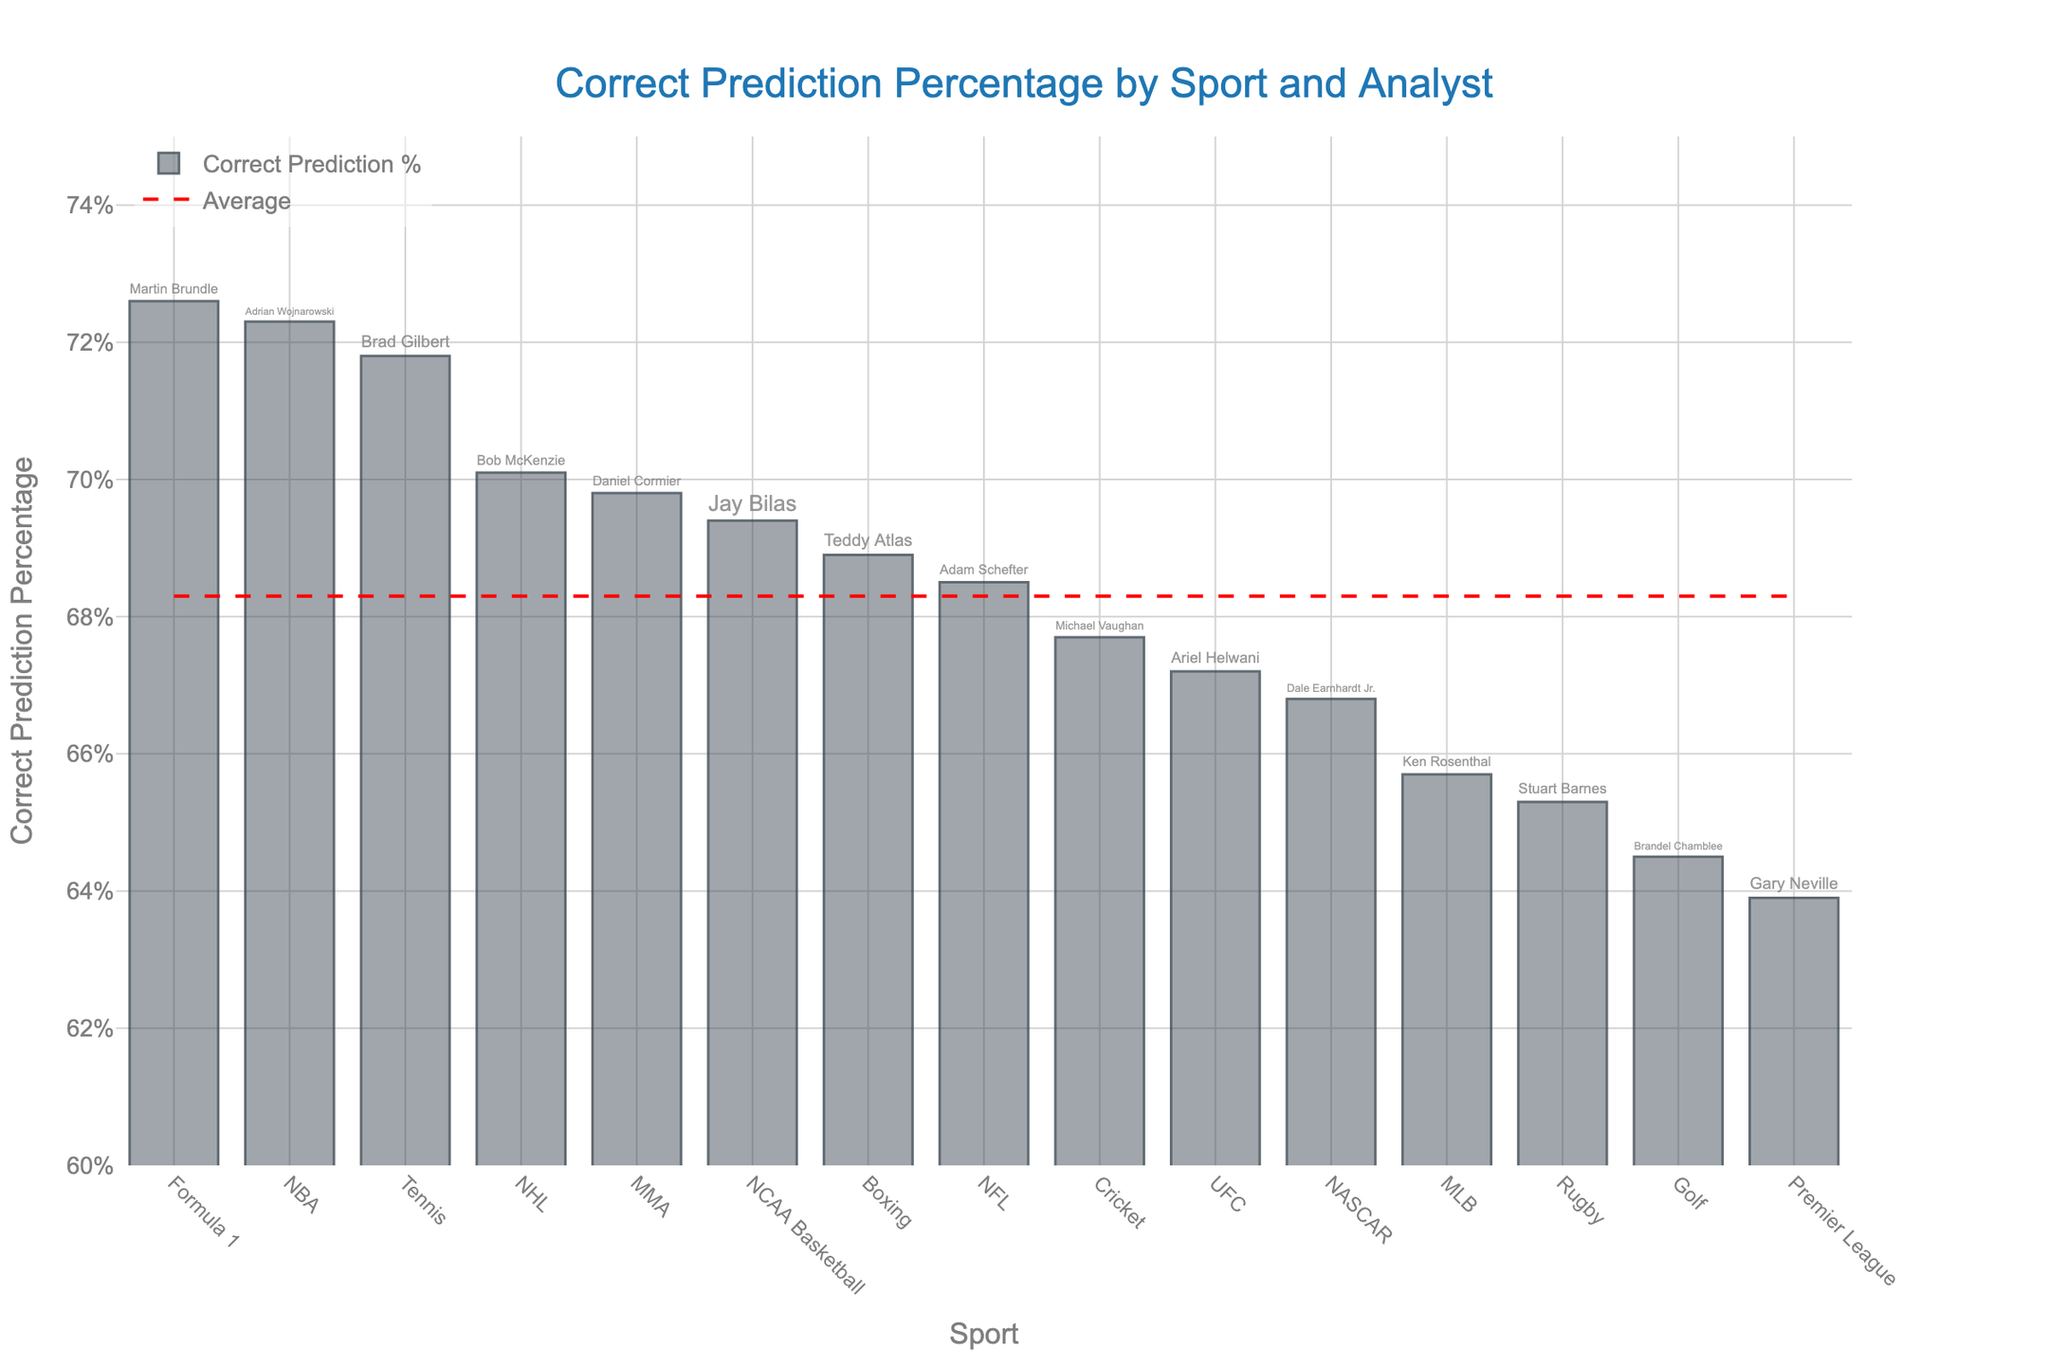What's the percentage of correct predictions made by Adrian Wojnarowski for the NBA? The bar representing the NBA is labeled with the analyst Adrian Wojnarowski, and the bar reaches the 72.3% mark. Thus, the percentage of correct predictions made by Adrian Wojnarowski for the NBA is 72.3%.
Answer: 72.3% Which analyst has the highest percentage of correct predictions, and for which sport? By examining the heights of the bars and the text labels, it's evident that the tallest bar, corresponding to a correct prediction percentage of 72.6%, is for Martin Brundle in Formula 1.
Answer: Martin Brundle, Formula 1 Compare the correct prediction percentages of Adam Schefter and Ariel Helwani. Who has a higher percentage, and by how much? Adam Schefter's correct prediction percentage for NFL is 68.5%, while Ariel Helwani's for UFC is 67.2%. Subtracting the two values gives 68.5% - 67.2% = 1.3%, so Adam Schefter has a higher percentage by 1.3%.
Answer: Adam Schefter by 1.3% What is the average correct prediction percentage across all analysts? The red dashed line represents the average percentage. By looking at its placement on the y-axis, it aligns with approximately 68.6%.
Answer: 68.6% Which sports have analysts with a correct prediction percentage below the average? The average is 68.6%. Observing the bars below the red dashed line:
- Gary Neville (Premier League) at 63.9%
- Ken Rosenthal (MLB) at 65.7%
- Stuart Barnes (Rugby) at 65.3%
- Brandel Chamblee (Golf) at 64.5%
Hence, analysts for Premier League, MLB, Rugby, and Golf have correct prediction percentages below the average.
Answer: Premier League, MLB, Rugby, Golf What's the difference between the highest and lowest correct prediction percentages? The highest percentage is 72.6% (Martin Brundle, Formula 1) and the lowest is 63.9% (Gary Neville, Premier League). Subtracting these gives 72.6% - 63.9% = 8.7%.
Answer: 8.7% Do any analysts who cover team sports have a prediction percentage above 70%? Team sports analysts with percentages above 70%:
- Adrian Wojnarowski (NBA) at 72.3%
- Bob McKenzie (NHL) at 70.1%
Therefore, both Adrian Wojnarowski and Bob McKenzie have percentages above 70%.
Answer: Adrian Wojnarowski, Bob McKenzie Who has a higher prediction percentage, Brad Gilbert for Tennis or Jay Bilas for NCAA Basketball, and by how much? Brad Gilbert's correct prediction percentage for Tennis is 71.8%, while Jay Bilas's for NCAA Basketball is 69.4%. Subtracting these gives 71.8% - 69.4% = 2.4%.
Answer: Brad Gilbert by 2.4% What's the range of correct prediction percentages among individual sport analysts (Tennis, Golf, UFC, MMA, Boxing, etc.)? Individual sports and their percentages:
- Brad Gilbert (Tennis) at 71.8%
- Ariel Helwani (UFC) at 67.2%
- Brandel Chamblee (Golf) at 64.5%
- Teddy Atlas (Boxing) at 68.9%
- Daniel Cormier (MMA) at 69.8%
The range is calculated by subtracting the lowest percentage (64.5%) from the highest (71.8%) = 71.8% - 64.5% = 7.3%.
Answer: 7.3% 